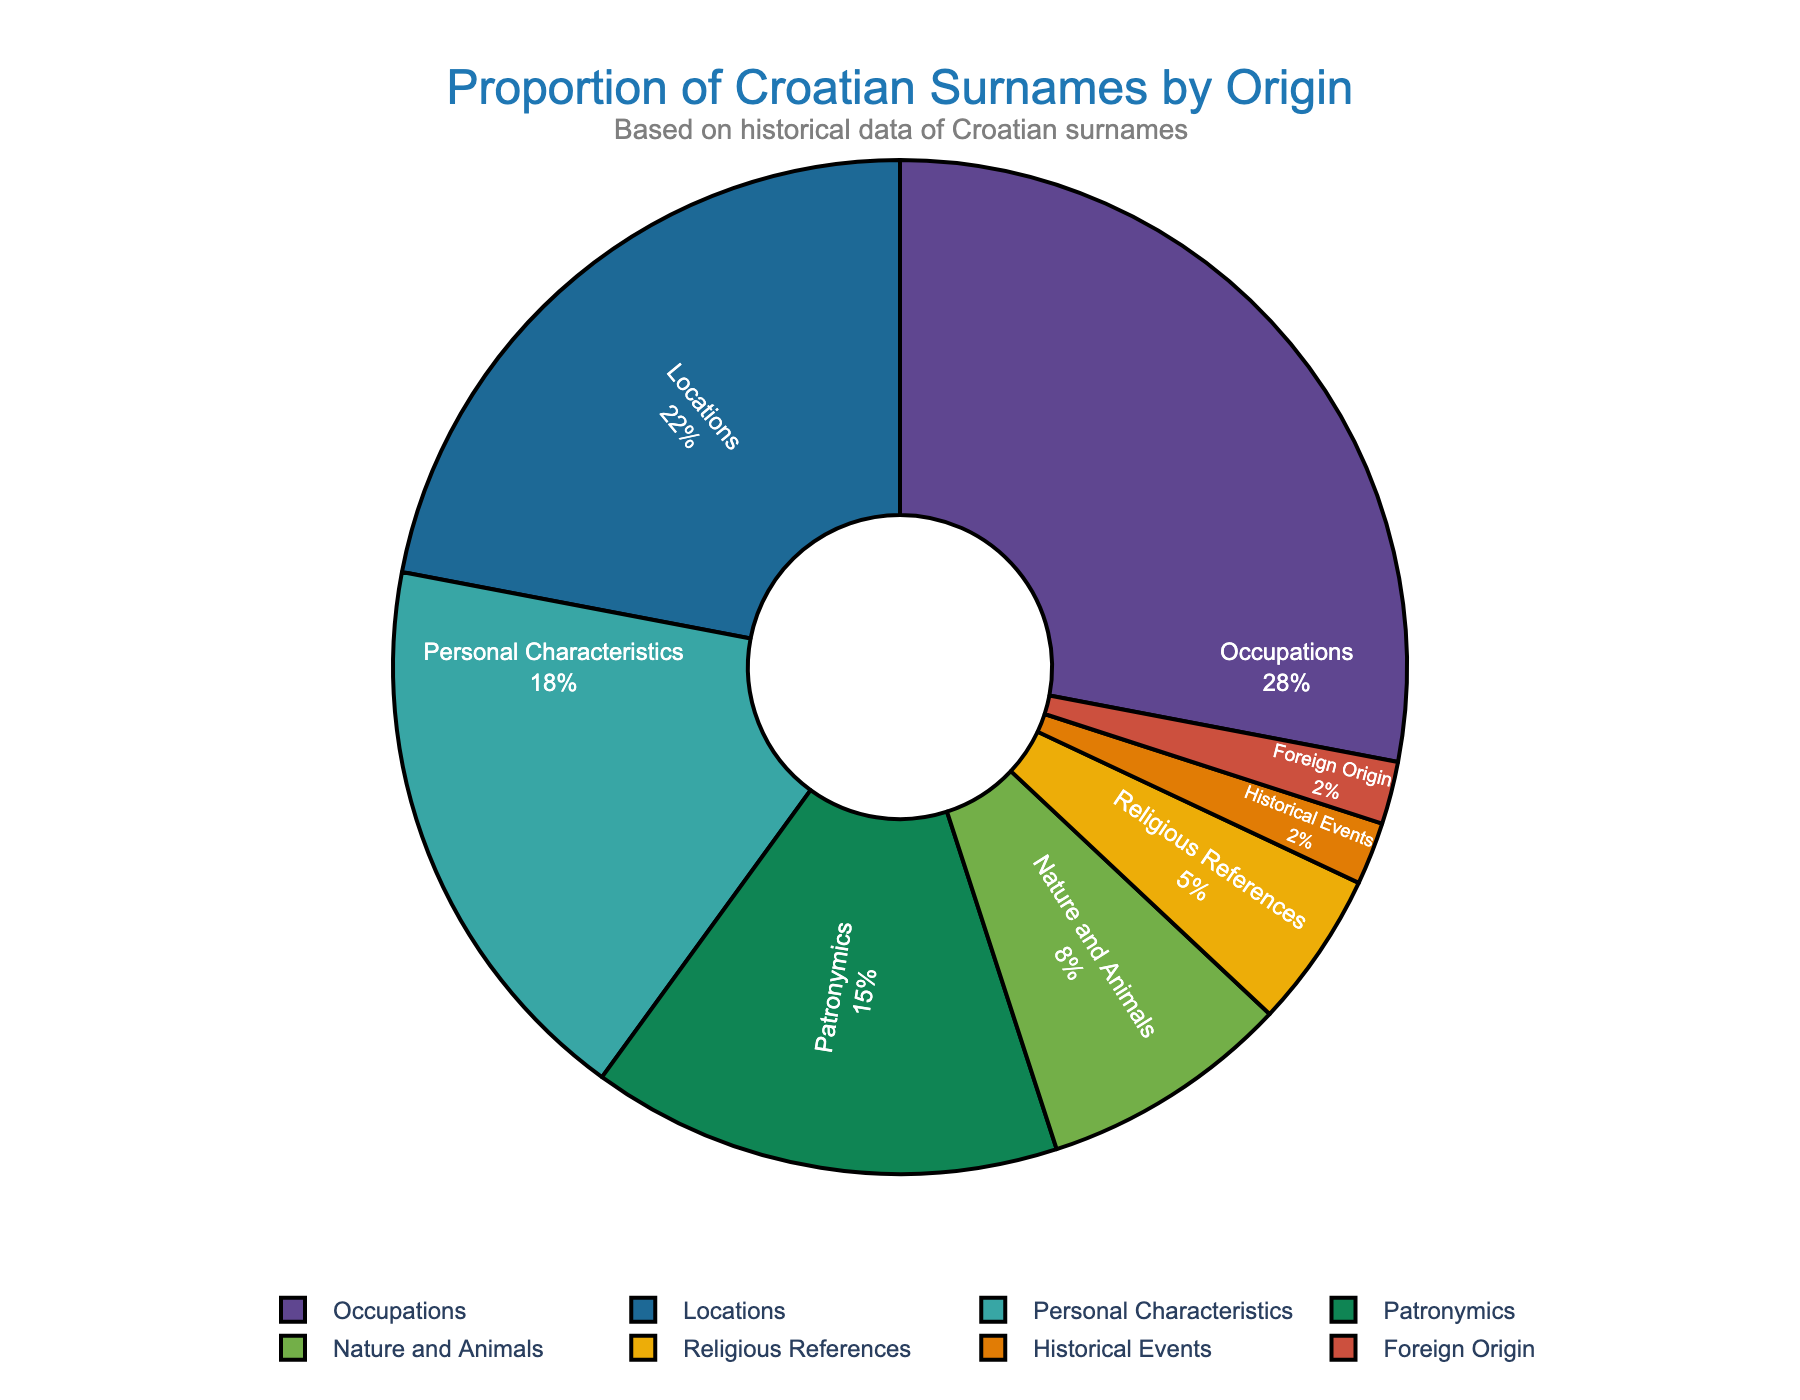Which category has the highest proportion of Croatian surnames? The occupation category represents the largest section of the pie chart, indicating that it has the highest proportion of Croatian surnames.
Answer: Occupations How much greater is the percentage of surnames derived from occupations compared to those from personal characteristics? The percentage of surnames from occupations is 28%, and from personal characteristics is 18%. The difference is calculated by subtracting 18% from 28%.
Answer: 10% What is the combined percentage of surnames derived from nature and animals and religious references? The percentage for nature and animals is 8%, and for religious references is 5%. Adding these together gives the combined percentage.
Answer: 13% Which categories have an equal proportion of Croatian surnames? The historical events and foreign origin categories both have 2% as shown in the pie chart, indicating that these categories have an equal proportion.
Answer: Historical Events and Foreign Origin How does the proportion of surnames derived from locations compare to those from patronymics? The proportion of surnames from locations is 22%, while those from patronymics is 15%. The percentage from locations is greater.
Answer: Locations What percentage of Croatian surnames is not derived from either occupations or locations? Occupations and locations together make up 28% + 22% = 50%. Subtracting this from 100% gives the percentage from other categories.
Answer: 50% What is the second most common origin for Croatian surnames? The pie chart shows that locations occupy the second largest section of the pie after occupations, indicating that it is the second most common origin.
Answer: Locations Calculate the average percentage of Croatian surnames derived from nature and animals, religious references, and historical events. The percentages for these categories are 8%, 5%, and 2%, respectively. The average is calculated by summing these (8 + 5 + 2 = 15) and dividing by the number of categories (3).
Answer: 5% Which category is represented by the yellow section of the pie chart? By visually referring to the color scheme in the chart, the yellow section corresponds to the category of foreign origin.
Answer: Foreign Origin How do the proportions of surnames derived from occupations and those derived from personal characteristics differ visually? The section for occupations is significantly larger than the section for personal characteristics, indicating a notable difference in proportion, with occupations being more prevalent.
Answer: Occupations are larger than Personal Characteristics 